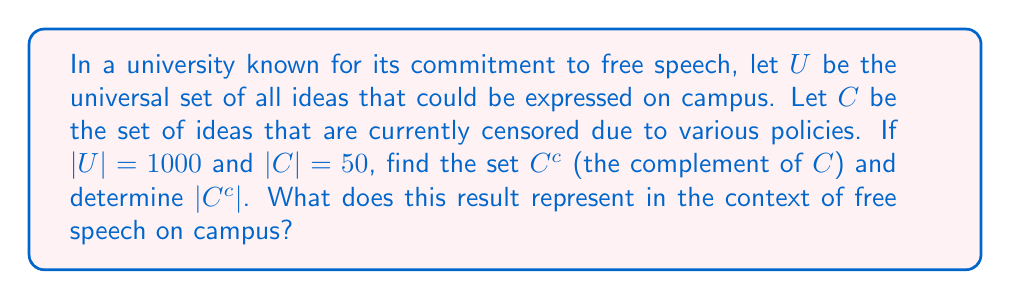Provide a solution to this math problem. To solve this problem, we need to understand the concept of set complement and apply it to the given scenario:

1) The universal set $U$ represents all possible ideas that could be expressed on campus.
2) Set $C$ represents the ideas that are censored.
3) The complement of $C$, denoted as $C^c$, represents all ideas in $U$ that are not in $C$.

Mathematically, we can express this as:

$$C^c = U \setminus C$$

Where $\setminus$ represents the set difference operation.

To find $|C^c|$, we can use the following property:

$$|C^c| = |U| - |C|$$

Given:
$|U| = 1000$
$|C| = 50$

Substituting these values:

$$|C^c| = 1000 - 50 = 950$$

In the context of free speech on campus, $C^c$ represents the set of all ideas that are not censored, i.e., the ideas that can be freely expressed. The cardinality of this set, $|C^c| = 950$, represents the number of types of ideas that can be freely expressed on campus.
Answer: $C^c = U \setminus C$, where $C^c$ represents all ideas that are not censored.
$|C^c| = 950$, which represents the number of types of ideas that can be freely expressed on campus. 